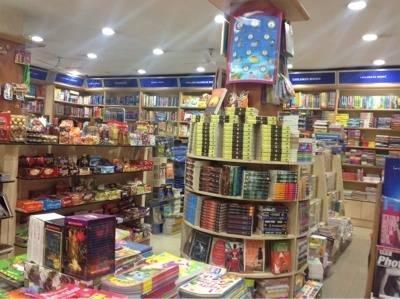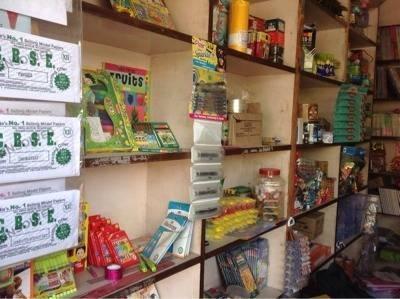The first image is the image on the left, the second image is the image on the right. For the images displayed, is the sentence "There are books on a table." factually correct? Answer yes or no. Yes. 